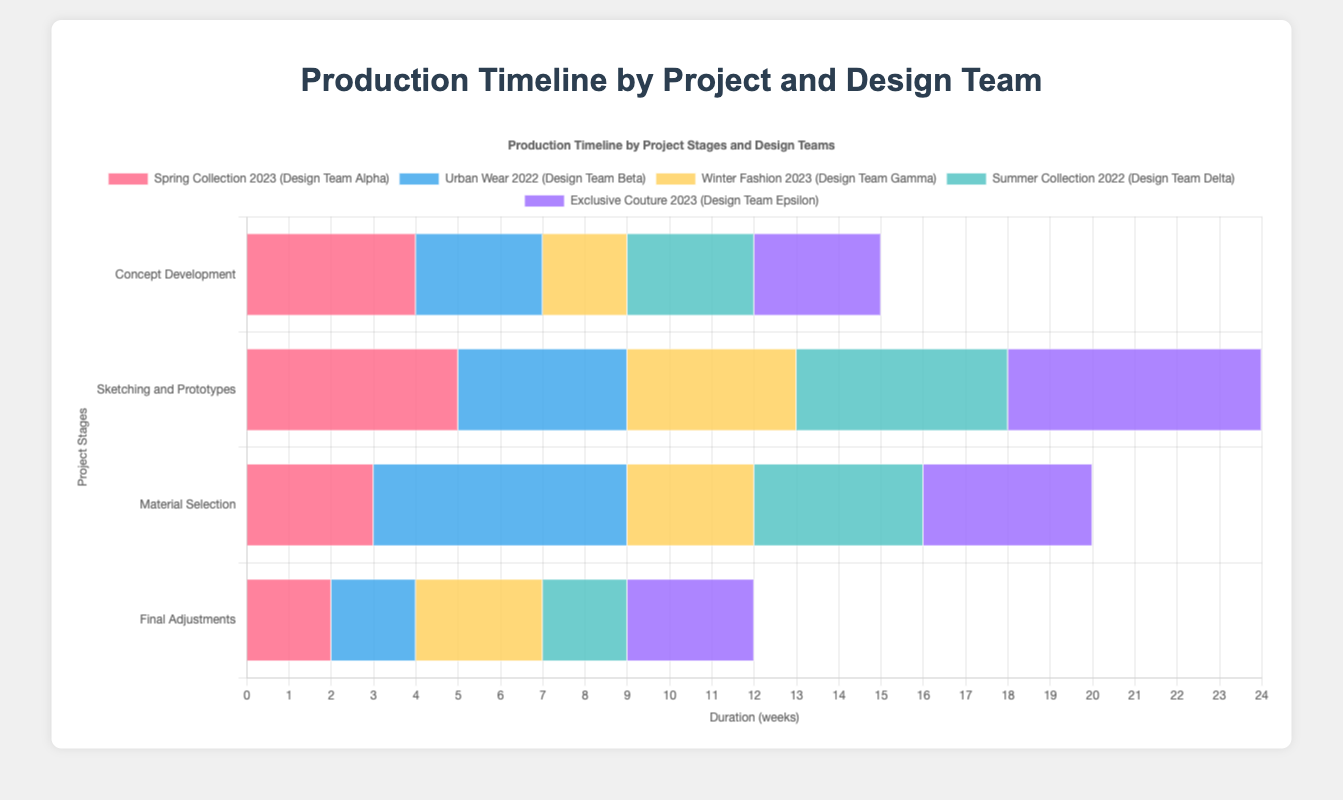What is the total duration of the Spring Collection 2023 project? To find the total duration, we sum up the durations of all stages: 4 (Concept Development) + 5 (Sketching and Prototypes) + 3 (Material Selection) + 2 (Final Adjustments) = 14 weeks
Answer: 14 weeks Which design team had the longest single stage duration, and what was that duration? By looking at the longest bars in the figure, we identify Design Team Beta with the "Sample Creation" stage lasting 6 weeks.
Answer: Design Team Beta, 6 weeks Who spent more weeks on Concept Development vs. Trend Analysis? For Concept Development, Design Team Alpha spent 4 weeks. For Trend Analysis, Design Team Gamma spent 2 weeks. Therefore, Concept Development took more time.
Answer: Design Team Alpha, 4 weeks How many weeks did Design Team Delta spend on stages involving "Feedback and Revisions" and "Market Research"? Summing the respective durations: 2 (Feedback and Revisions) + 3 (Market Research) = 5 weeks.
Answer: 5 weeks What is the average duration of all stages for the Exclusive Couture 2023 project? The stages' durations are: 3 (Concept Ideation), 6 (Detailed Designing), 4 (Sample Making), 3 (Approval and Refinement). Summing gives 3 + 6 + 4 + 3 = 16 weeks, and the average is 16/4 = 4 weeks.
Answer: 4 weeks Are there any stages that last exactly 3 weeks, and if so, which projects and teams do they belong to? Yes, the following stages last exactly 3 weeks:
- Spring Collection 2023: Material Selection (Design Team Alpha)
- Urban Wear 2022: Research and Mood Boards (Design Team Beta)
- Winter Fashion 2023: Trend Analysis and Final Adjustments (Design Team Gamma)
- Summer Collection 2022: Prototyping (Design Team Delta)
- Exclusive Couture 2023: Concept Ideation and Approval and Refinement (Design Team Epsilon)
Answer: Multiple stages, multiple projects 